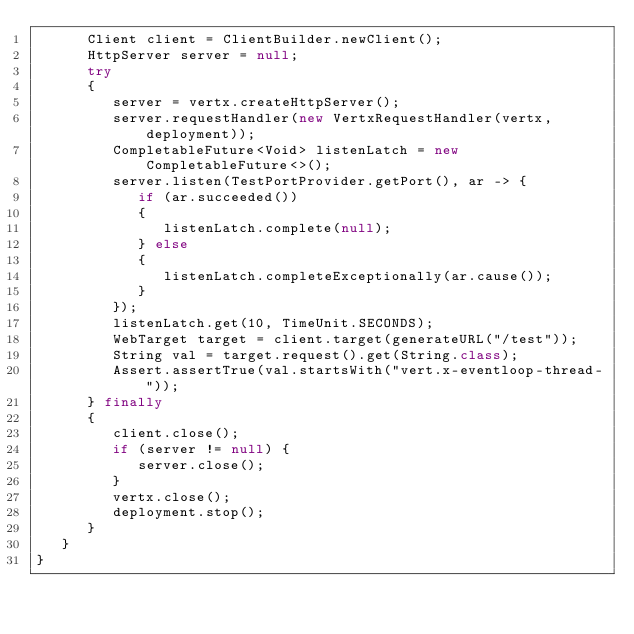Convert code to text. <code><loc_0><loc_0><loc_500><loc_500><_Java_>      Client client = ClientBuilder.newClient();
      HttpServer server = null;
      try
      {
         server = vertx.createHttpServer();
         server.requestHandler(new VertxRequestHandler(vertx, deployment));
         CompletableFuture<Void> listenLatch = new CompletableFuture<>();
         server.listen(TestPortProvider.getPort(), ar -> {
            if (ar.succeeded())
            {
               listenLatch.complete(null);
            } else
            {
               listenLatch.completeExceptionally(ar.cause());
            }
         });
         listenLatch.get(10, TimeUnit.SECONDS);
         WebTarget target = client.target(generateURL("/test"));
         String val = target.request().get(String.class);
         Assert.assertTrue(val.startsWith("vert.x-eventloop-thread-"));
      } finally
      {
         client.close();
         if (server != null) {
            server.close();
         }
         vertx.close();
         deployment.stop();
      }
   }
}
</code> 